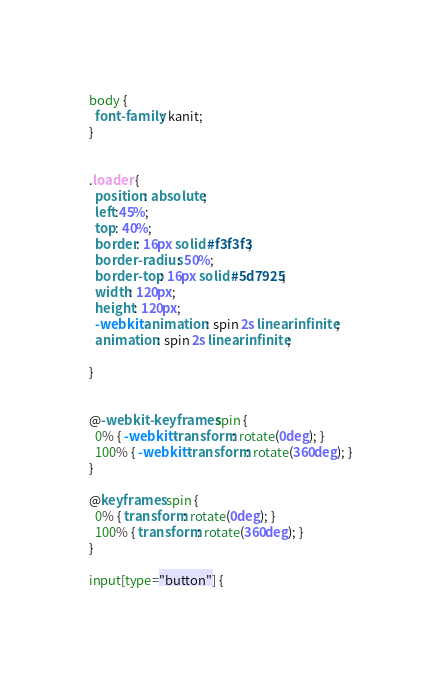Convert code to text. <code><loc_0><loc_0><loc_500><loc_500><_CSS_>body {
  font-family: kanit;
}


.loader {
  position: absolute;
  left:45%;
  top: 40%;
  border: 16px solid #f3f3f3;
  border-radius: 50%;
  border-top: 16px solid #5d7925;
  width: 120px;
  height: 120px;
  -webkit-animation: spin 2s linear infinite;
  animation: spin 2s linear infinite;
  
}


@-webkit-keyframes spin {
  0% { -webkit-transform: rotate(0deg); }
  100% { -webkit-transform: rotate(360deg); }
}

@keyframes spin {
  0% { transform: rotate(0deg); }
  100% { transform: rotate(360deg); }
}

input[type="button"] {</code> 